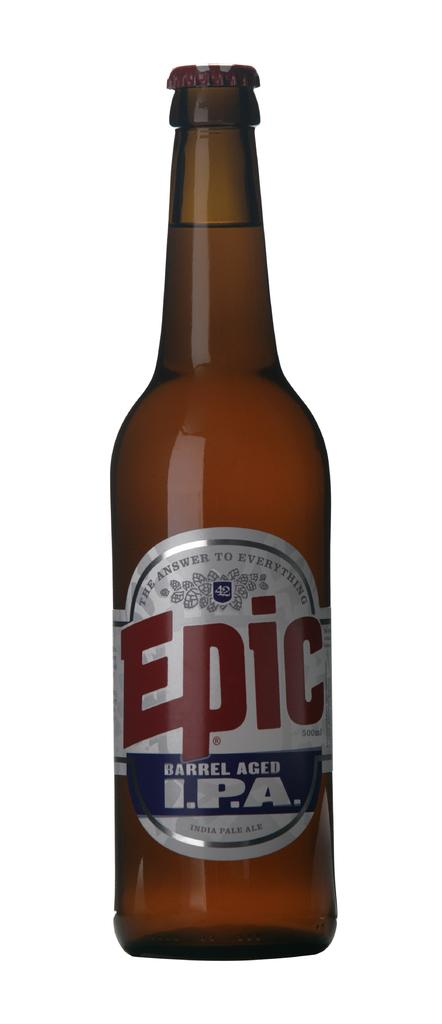<image>
Give a short and clear explanation of the subsequent image. A bottle of Epic beer that is a Barrel Aged I.P.A 